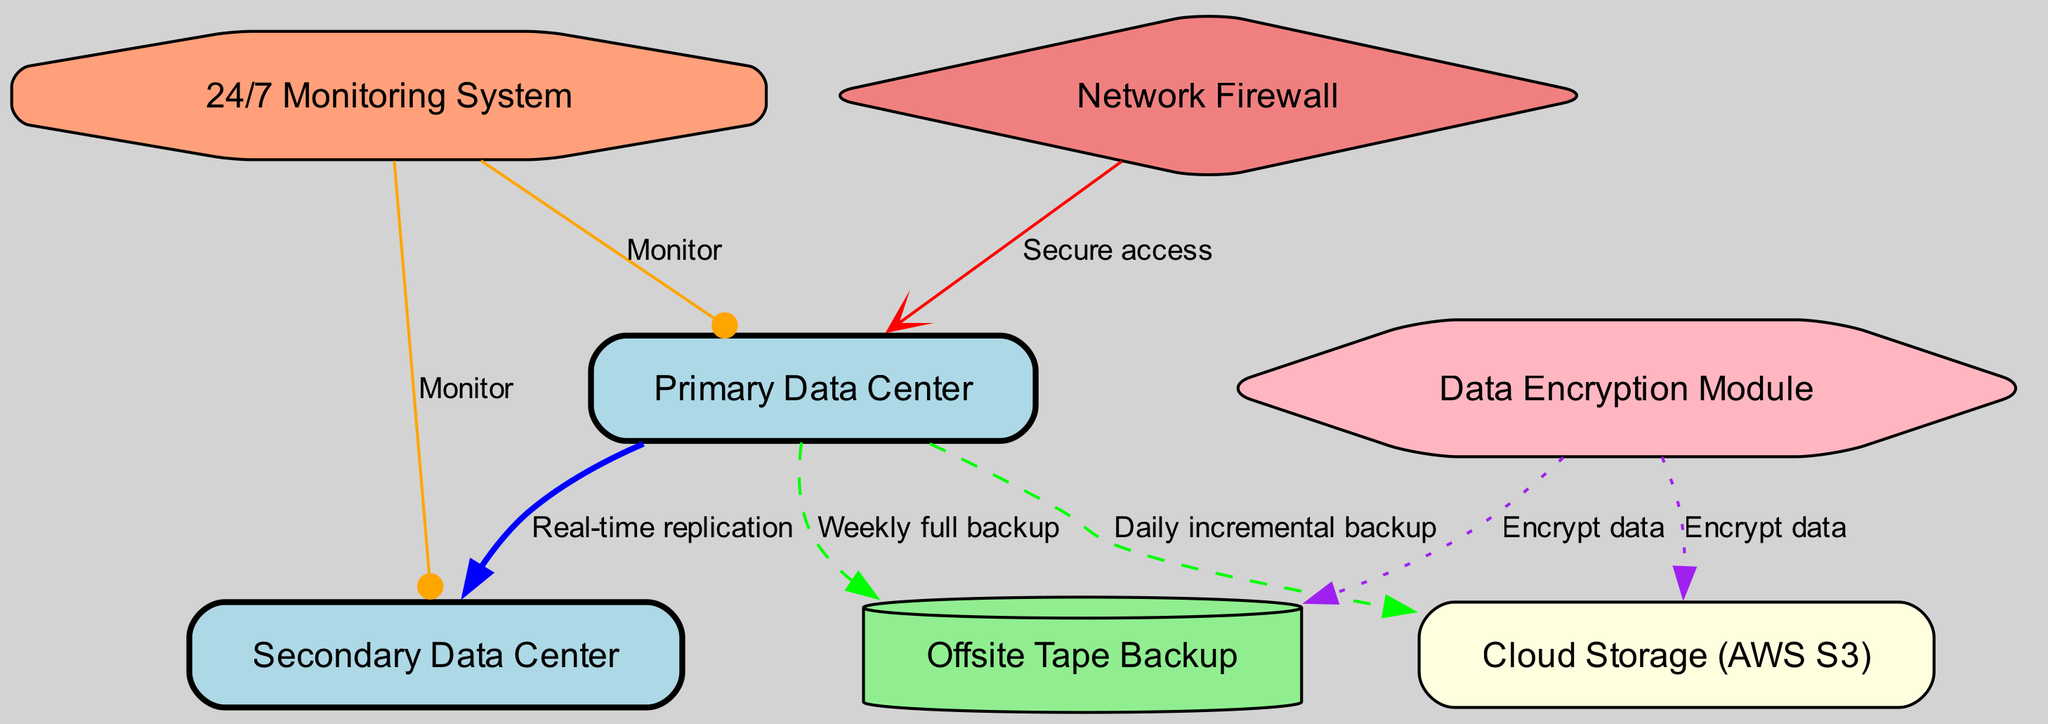What is the total number of nodes in the diagram? The diagram includes nodes for the Primary Data Center, Secondary Data Center, Cloud Storage, Offsite Tape Backup, Network Firewall, Data Encryption Module, and 24/7 Monitoring System. Counting these gives a total of seven nodes.
Answer: 7 What type of backup is performed to the cloud storage? The diagram indicates that a "Daily incremental backup" is the method used for backing up data to the Cloud Storage from the Primary Data Center.
Answer: Daily incremental backup Which node is connected to both the Primary and Secondary Data Center for monitoring? In the diagram, the 24/7 Monitoring System connects to both the Primary Data Center and the Secondary Data Center, depicted with labeled edges leading to both nodes.
Answer: 24/7 Monitoring System What type of data protection is applied to the tape backup? The diagram shows that the data sent to the Offsite Tape Backup is also encrypted, as indicated by the edge labeled "Encrypt data" that connects the Data Encryption Module to the Offsite Tape Backup.
Answer: Encrypt data How many connections (edges) are associated with the Primary Data Center? Examining the diagram, the Primary Data Center has four outgoing connections: to the Secondary Data Center (Real-time replication), Cloud Storage (Daily incremental backup), Tape Backup (Weekly full backup), and the 24/7 Monitoring System (Monitor). Counting these gives a total of four outgoing edges.
Answer: 4 Which component ensures secure access to the Primary Data Center? The diagram specifies that the Network Firewall, which is clearly labeled, is responsible for secure access to the Primary Data Center with the edge labeled "Secure access."
Answer: Network Firewall What is the frequency of backups to the Offsite Tape Backup? According to the diagram, the backups to the Offsite Tape Backup are performed weekly, as referred to in the edge labeled "Weekly full backup."
Answer: Weekly full backup In what form is data secured before being sent to the Cloud Storage? The diagram indicates that data is secured before transmission to Cloud Storage by the Data Encryption Module, shown by the edge labeled "Encrypt data."
Answer: Encrypt data 